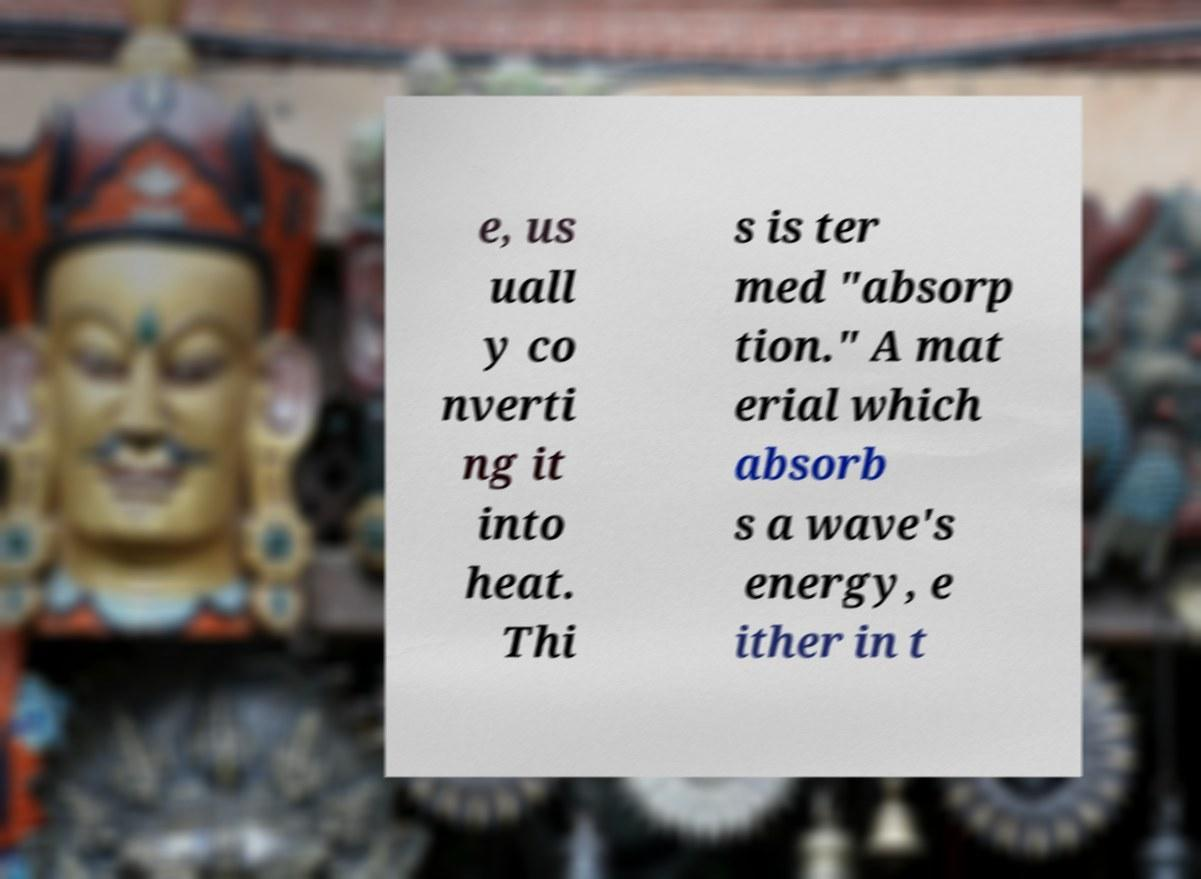For documentation purposes, I need the text within this image transcribed. Could you provide that? e, us uall y co nverti ng it into heat. Thi s is ter med "absorp tion." A mat erial which absorb s a wave's energy, e ither in t 